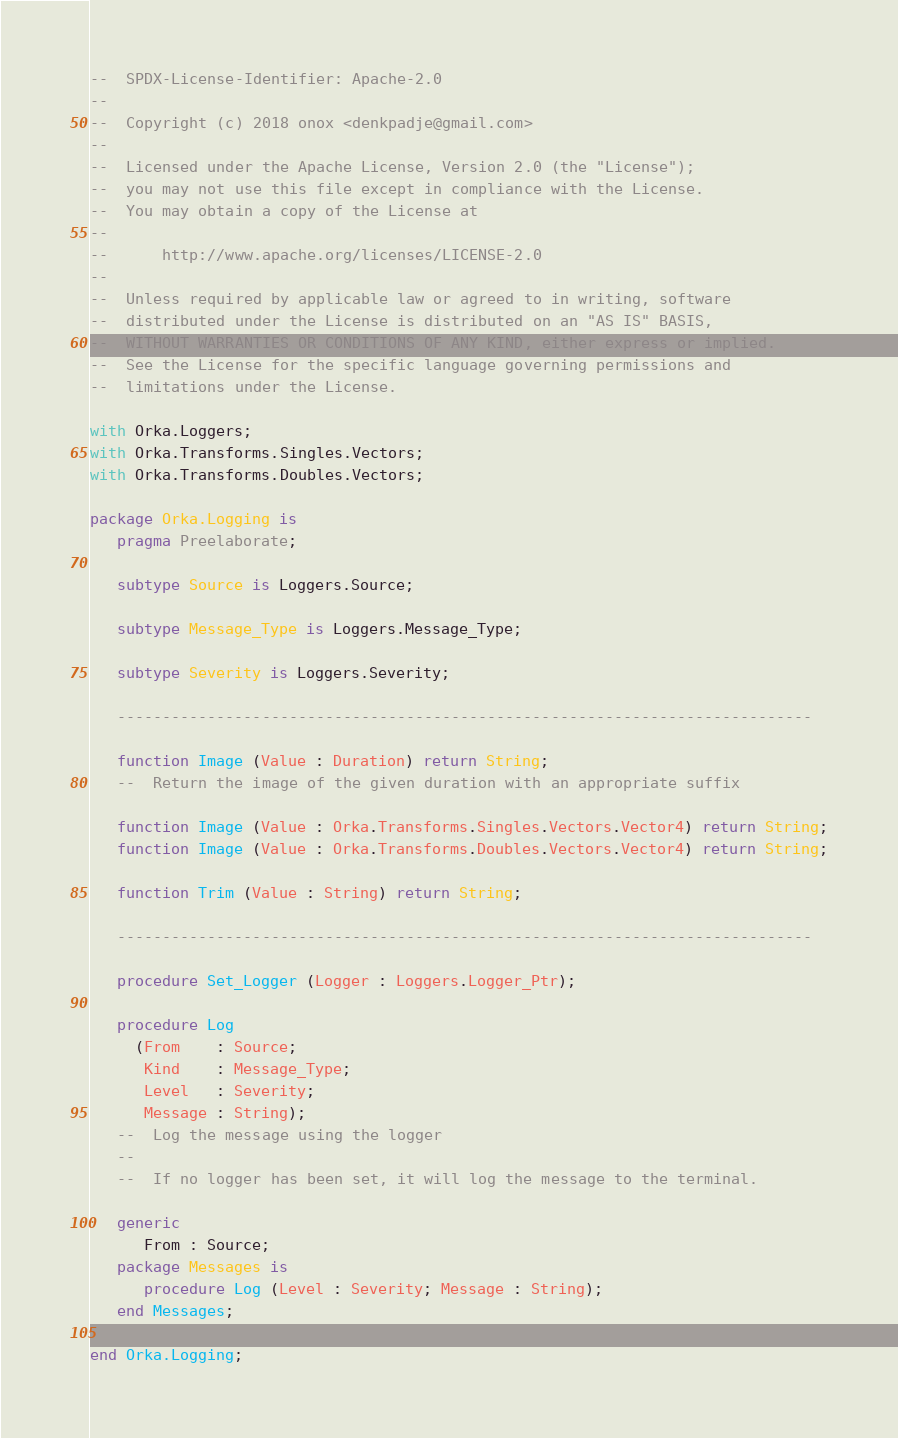<code> <loc_0><loc_0><loc_500><loc_500><_Ada_>--  SPDX-License-Identifier: Apache-2.0
--
--  Copyright (c) 2018 onox <denkpadje@gmail.com>
--
--  Licensed under the Apache License, Version 2.0 (the "License");
--  you may not use this file except in compliance with the License.
--  You may obtain a copy of the License at
--
--      http://www.apache.org/licenses/LICENSE-2.0
--
--  Unless required by applicable law or agreed to in writing, software
--  distributed under the License is distributed on an "AS IS" BASIS,
--  WITHOUT WARRANTIES OR CONDITIONS OF ANY KIND, either express or implied.
--  See the License for the specific language governing permissions and
--  limitations under the License.

with Orka.Loggers;
with Orka.Transforms.Singles.Vectors;
with Orka.Transforms.Doubles.Vectors;

package Orka.Logging is
   pragma Preelaborate;

   subtype Source is Loggers.Source;

   subtype Message_Type is Loggers.Message_Type;

   subtype Severity is Loggers.Severity;

   -----------------------------------------------------------------------------

   function Image (Value : Duration) return String;
   --  Return the image of the given duration with an appropriate suffix

   function Image (Value : Orka.Transforms.Singles.Vectors.Vector4) return String;
   function Image (Value : Orka.Transforms.Doubles.Vectors.Vector4) return String;

   function Trim (Value : String) return String;

   -----------------------------------------------------------------------------

   procedure Set_Logger (Logger : Loggers.Logger_Ptr);

   procedure Log
     (From    : Source;
      Kind    : Message_Type;
      Level   : Severity;
      Message : String);
   --  Log the message using the logger
   --
   --  If no logger has been set, it will log the message to the terminal.

   generic
      From : Source;
   package Messages is
      procedure Log (Level : Severity; Message : String);
   end Messages;

end Orka.Logging;
</code> 